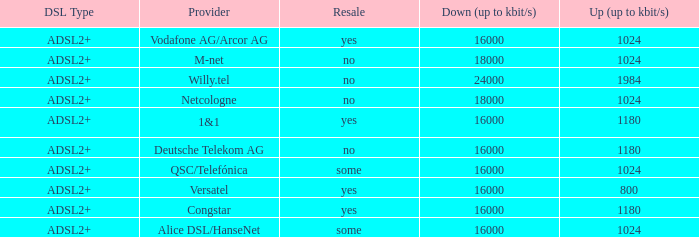How many providers are there where the resale category is yes and bandwith is up is 1024? 1.0. Can you give me this table as a dict? {'header': ['DSL Type', 'Provider', 'Resale', 'Down (up to kbit/s)', 'Up (up to kbit/s)'], 'rows': [['ADSL2+', 'Vodafone AG/Arcor AG', 'yes', '16000', '1024'], ['ADSL2+', 'M-net', 'no', '18000', '1024'], ['ADSL2+', 'Willy.tel', 'no', '24000', '1984'], ['ADSL2+', 'Netcologne', 'no', '18000', '1024'], ['ADSL2+', '1&1', 'yes', '16000', '1180'], ['ADSL2+', 'Deutsche Telekom AG', 'no', '16000', '1180'], ['ADSL2+', 'QSC/Telefónica', 'some', '16000', '1024'], ['ADSL2+', 'Versatel', 'yes', '16000', '800'], ['ADSL2+', 'Congstar', 'yes', '16000', '1180'], ['ADSL2+', 'Alice DSL/HanseNet', 'some', '16000', '1024']]} 